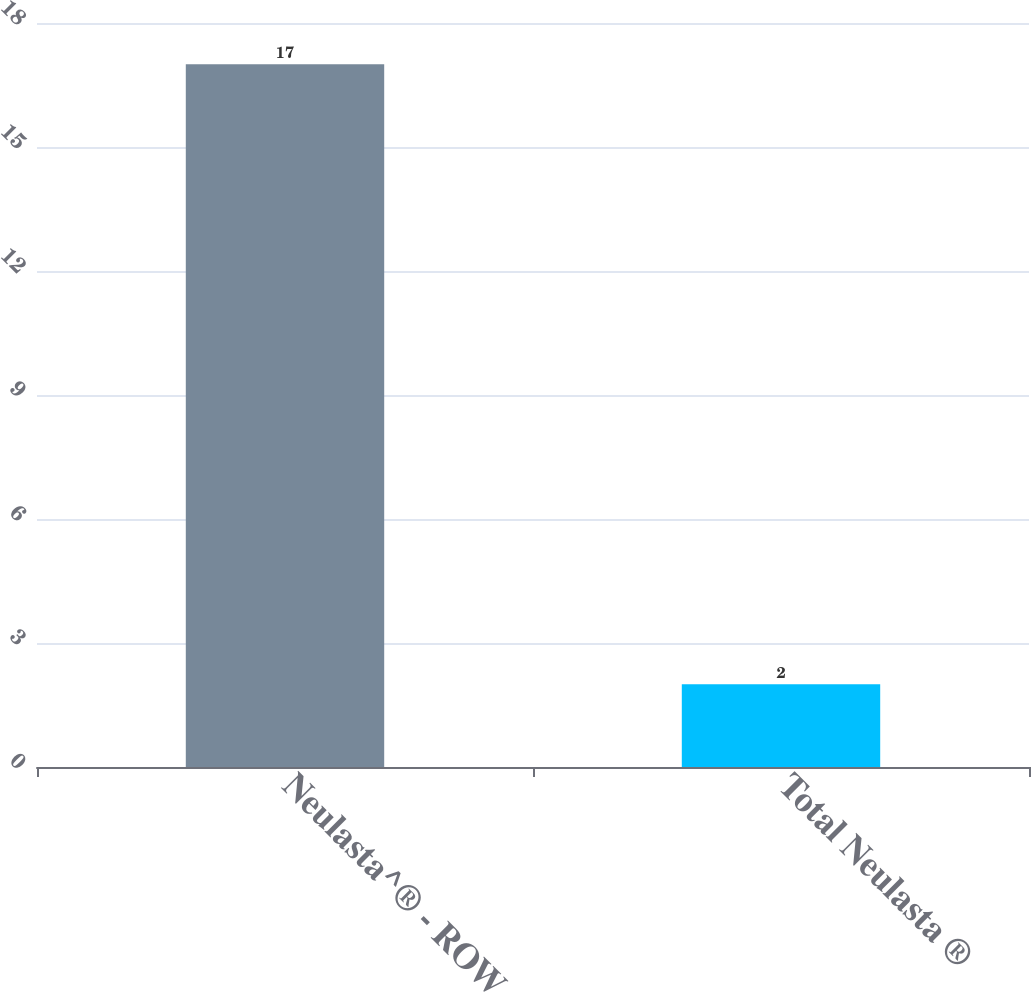Convert chart. <chart><loc_0><loc_0><loc_500><loc_500><bar_chart><fcel>Neulasta^® - ROW<fcel>Total Neulasta ®<nl><fcel>17<fcel>2<nl></chart> 